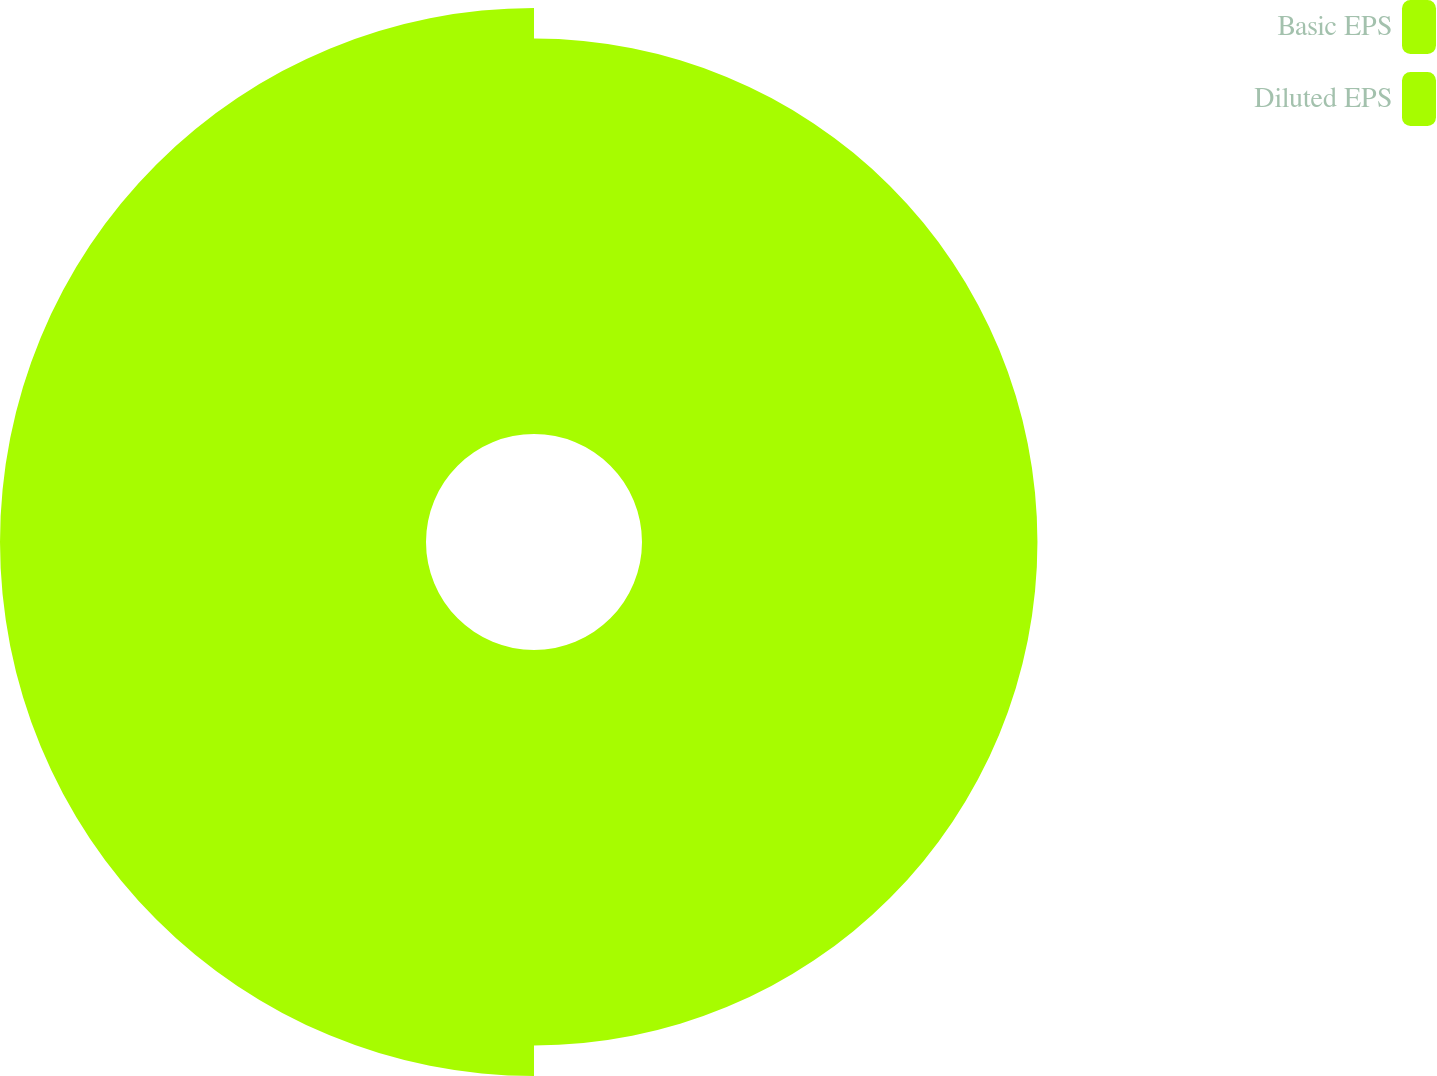<chart> <loc_0><loc_0><loc_500><loc_500><pie_chart><fcel>Basic EPS<fcel>Diluted EPS<nl><fcel>48.14%<fcel>51.86%<nl></chart> 